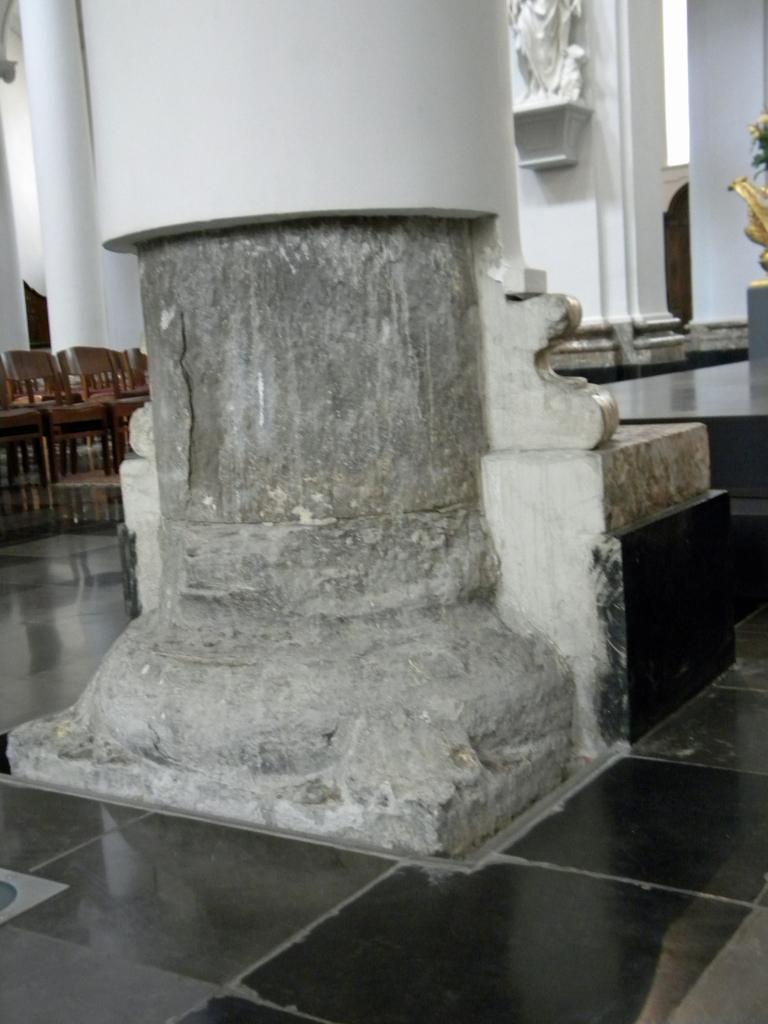What is the main structure visible in the image? There is a pillar in the image. What type of furniture can be seen in the background of the image? There are chairs in the background of the image. What decorative element is present on the wall in the image? There is a sculpture on the wall in the image. What grade does the wilderness receive in the image? There is no wilderness present in the image, so it cannot be graded. 